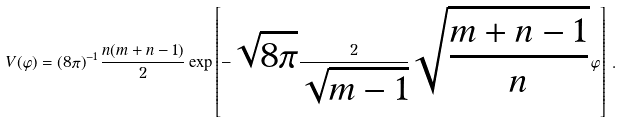<formula> <loc_0><loc_0><loc_500><loc_500>V ( \varphi ) = ( 8 \pi ) ^ { - 1 } \, \frac { n ( m + n - 1 ) } { 2 } \exp \left [ - \sqrt { 8 \pi } \frac { 2 } { \sqrt { m - 1 } } \sqrt { \frac { m + n - 1 } { n } } \, \varphi \right ] \, .</formula> 